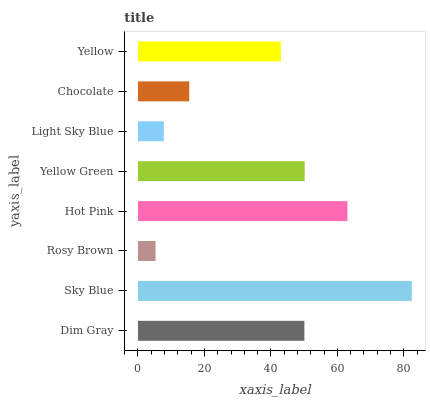Is Rosy Brown the minimum?
Answer yes or no. Yes. Is Sky Blue the maximum?
Answer yes or no. Yes. Is Sky Blue the minimum?
Answer yes or no. No. Is Rosy Brown the maximum?
Answer yes or no. No. Is Sky Blue greater than Rosy Brown?
Answer yes or no. Yes. Is Rosy Brown less than Sky Blue?
Answer yes or no. Yes. Is Rosy Brown greater than Sky Blue?
Answer yes or no. No. Is Sky Blue less than Rosy Brown?
Answer yes or no. No. Is Dim Gray the high median?
Answer yes or no. Yes. Is Yellow the low median?
Answer yes or no. Yes. Is Yellow Green the high median?
Answer yes or no. No. Is Dim Gray the low median?
Answer yes or no. No. 